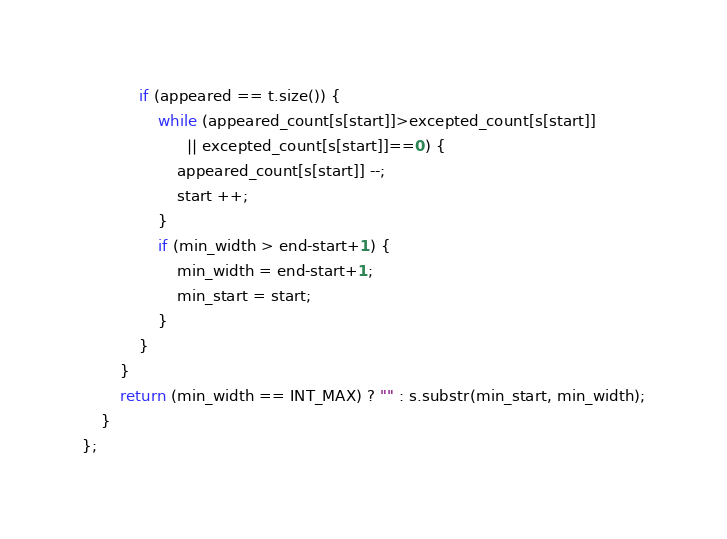<code> <loc_0><loc_0><loc_500><loc_500><_C++_>            if (appeared == t.size()) {
                while (appeared_count[s[start]]>excepted_count[s[start]] 
                      || excepted_count[s[start]]==0) {
                    appeared_count[s[start]] --;
                    start ++;
                }
                if (min_width > end-start+1) {
                    min_width = end-start+1;
                    min_start = start;
                }
            }
        }
        return (min_width == INT_MAX) ? "" : s.substr(min_start, min_width);
    }
};</code> 